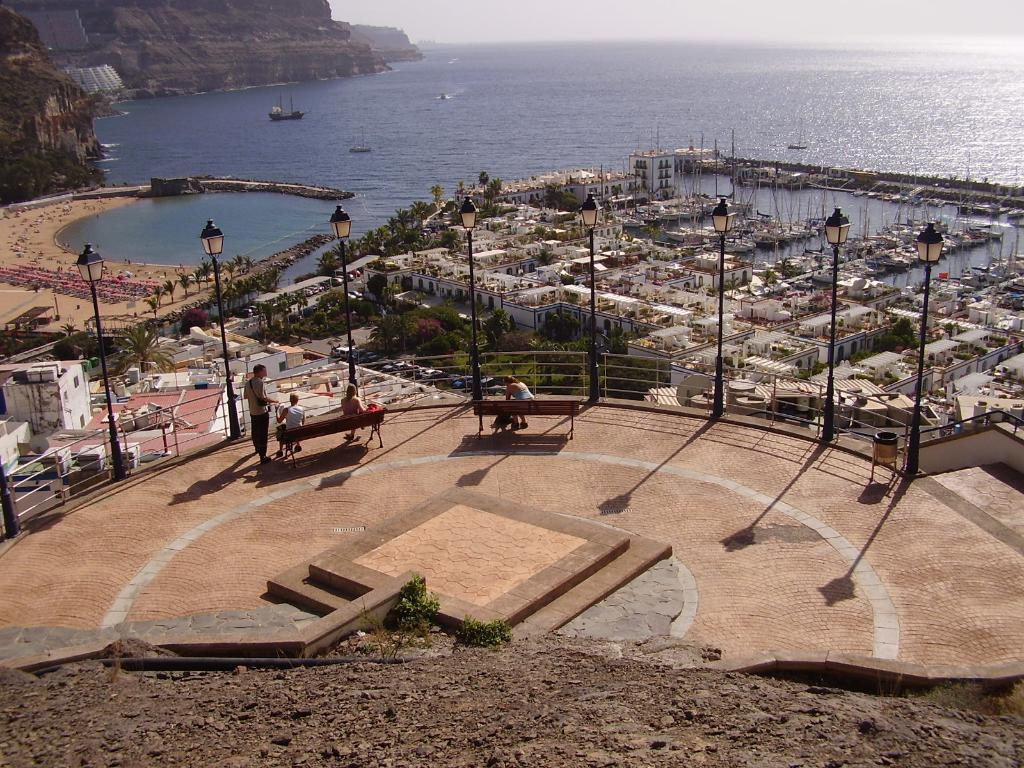What type of structures are located in the center of the image? There are houses in the center of the image. What type of seating can be seen in the image? There are benches in the image. What type of lighting is present in the image? There are light poles in the image. What type of natural feature is visible in the image? There is water visible in the image. What type of geographical feature is visible in the image? There are mountains in the image. What type of material is present at the bottom of the image? There are stones at the bottom of the image. Can you hear the goose playing the guitar in the image? There is no goose or guitar present in the image, so it is not possible to hear any music being played. 